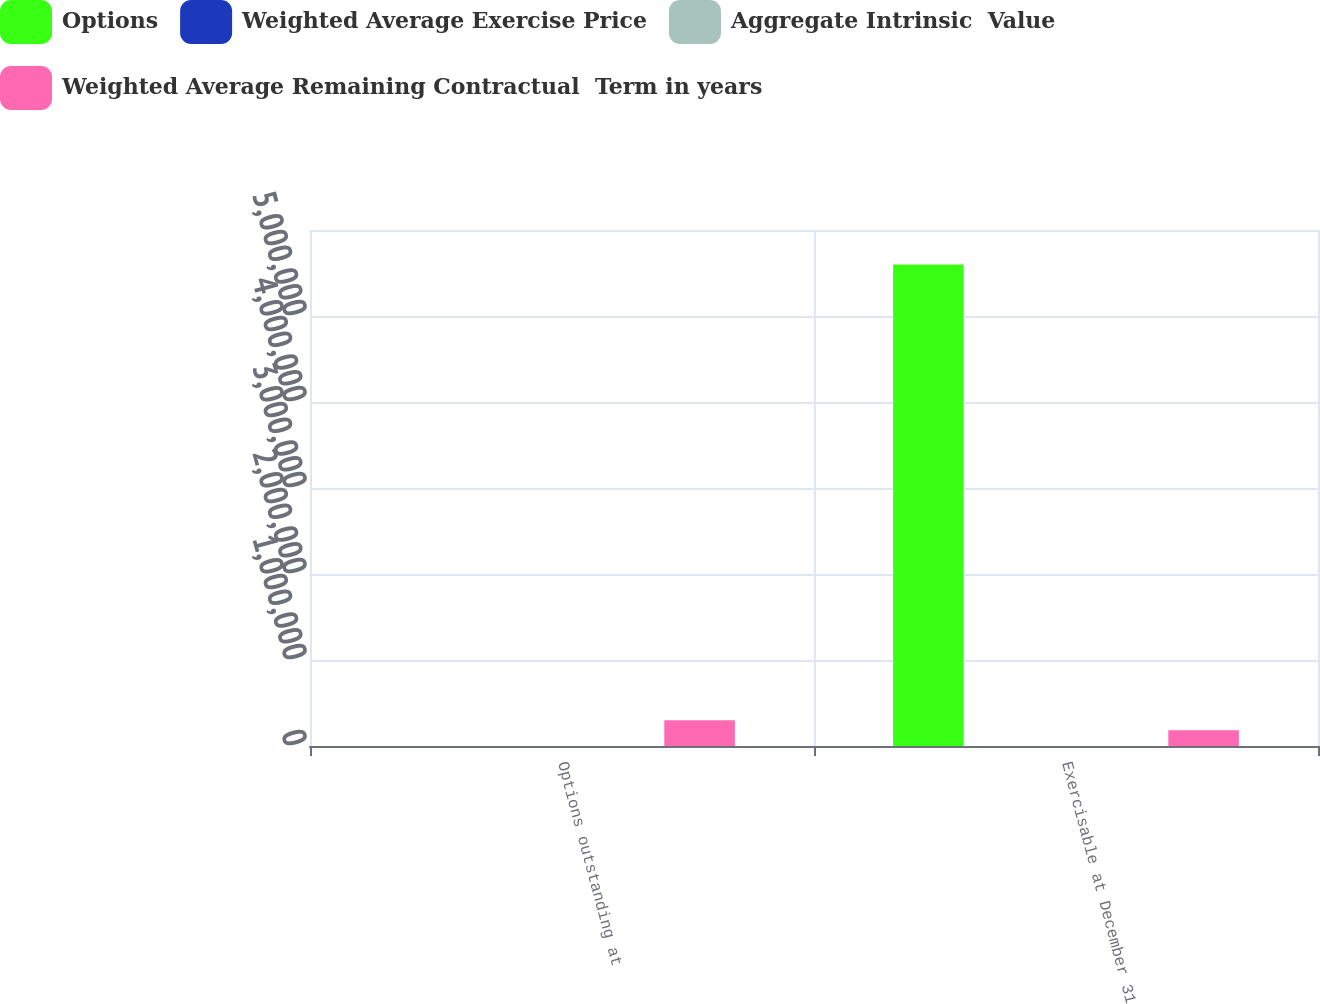<chart> <loc_0><loc_0><loc_500><loc_500><stacked_bar_chart><ecel><fcel>Options outstanding at<fcel>Exercisable at December 31<nl><fcel>Options<fcel>19.72<fcel>5.59795e+06<nl><fcel>Weighted Average Exercise Price<fcel>19.72<fcel>13.5<nl><fcel>Aggregate Intrinsic  Value<fcel>6.55<fcel>4.96<nl><fcel>Weighted Average Remaining Contractual  Term in years<fcel>300649<fcel>184019<nl></chart> 